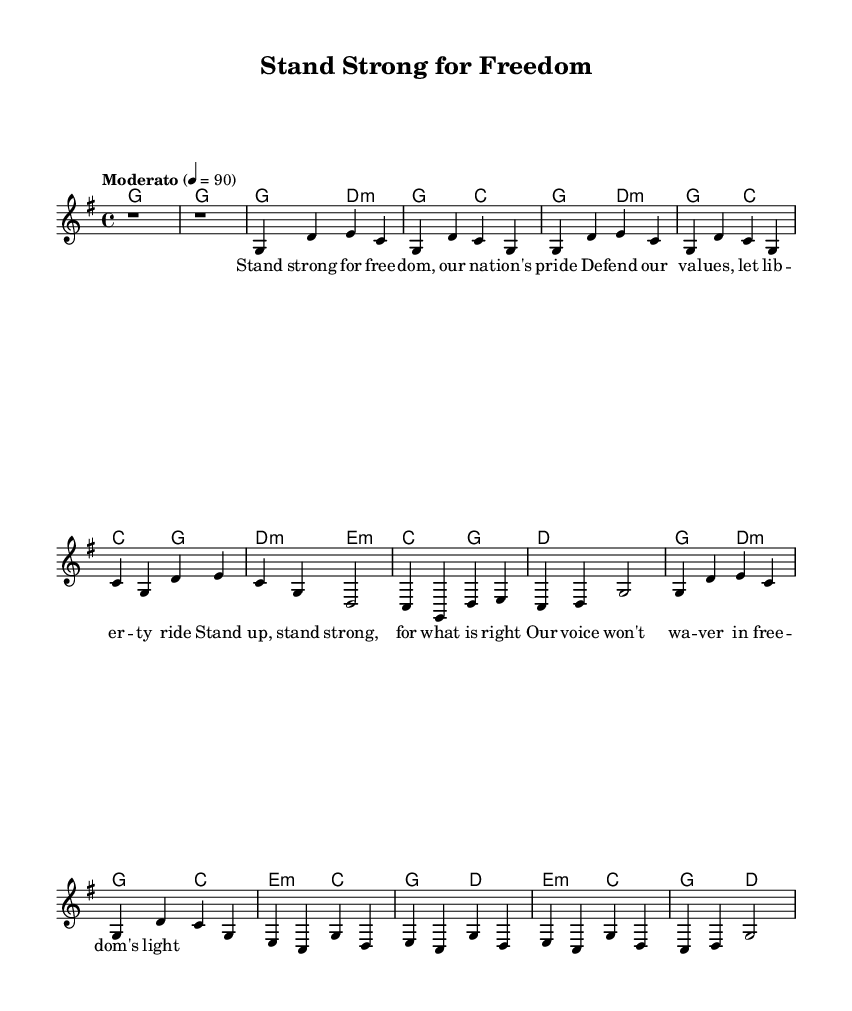What is the key signature of this music? The key signature is G major, which has one sharp (F#). The G major key is identified in the global section of the code.
Answer: G major What is the time signature of this music? The time signature is 4/4, which means there are four beats in a measure and the quarter note gets one beat. This is indicated in the global section of the score.
Answer: 4/4 What is the tempo marking for this piece? The tempo marking is "Moderato" with a metronome marking of 90 beats per minute. This is specified in the global settings of the music.
Answer: Moderato How many verses are present in this piece? There are two verses in the piece, with the second verse being abbreviated. The structure is noted in the melody section along with the chorus.
Answer: 2 What instrument is primarily featured in the score? The primary instrument is the voice, as indicated by the presence of a new Voice labeled "lead" that contains the melody.
Answer: Voice What is the emotional theme of the lyrics based on the title? The emotional theme of the lyrics revolves around defending freedom and national pride, as suggested by the title "Stand Strong for Freedom."
Answer: Defending freedom 